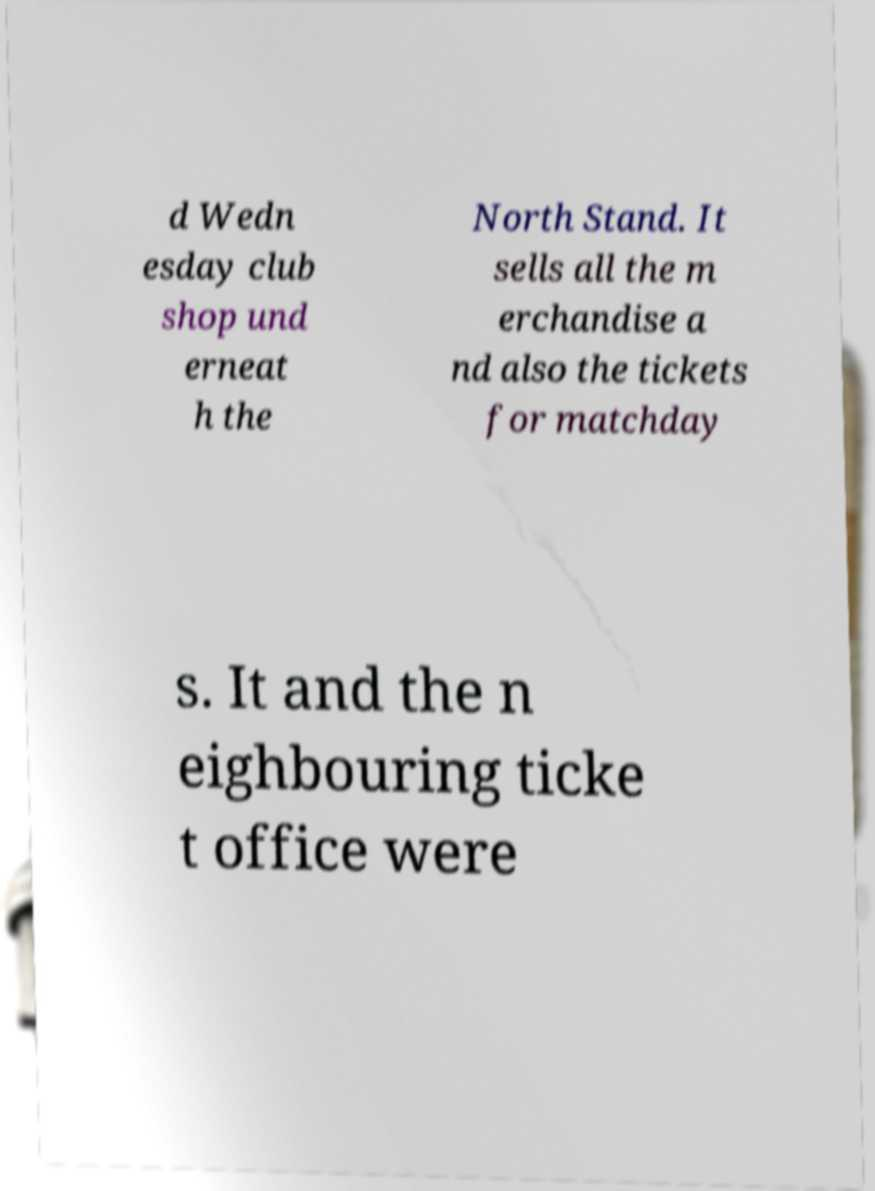Could you assist in decoding the text presented in this image and type it out clearly? d Wedn esday club shop und erneat h the North Stand. It sells all the m erchandise a nd also the tickets for matchday s. It and the n eighbouring ticke t office were 